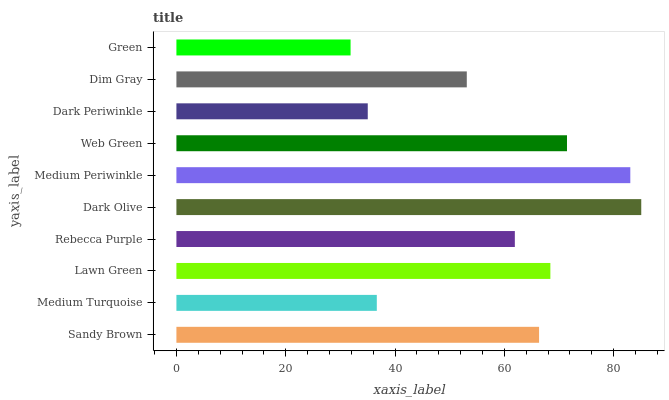Is Green the minimum?
Answer yes or no. Yes. Is Dark Olive the maximum?
Answer yes or no. Yes. Is Medium Turquoise the minimum?
Answer yes or no. No. Is Medium Turquoise the maximum?
Answer yes or no. No. Is Sandy Brown greater than Medium Turquoise?
Answer yes or no. Yes. Is Medium Turquoise less than Sandy Brown?
Answer yes or no. Yes. Is Medium Turquoise greater than Sandy Brown?
Answer yes or no. No. Is Sandy Brown less than Medium Turquoise?
Answer yes or no. No. Is Sandy Brown the high median?
Answer yes or no. Yes. Is Rebecca Purple the low median?
Answer yes or no. Yes. Is Medium Turquoise the high median?
Answer yes or no. No. Is Web Green the low median?
Answer yes or no. No. 